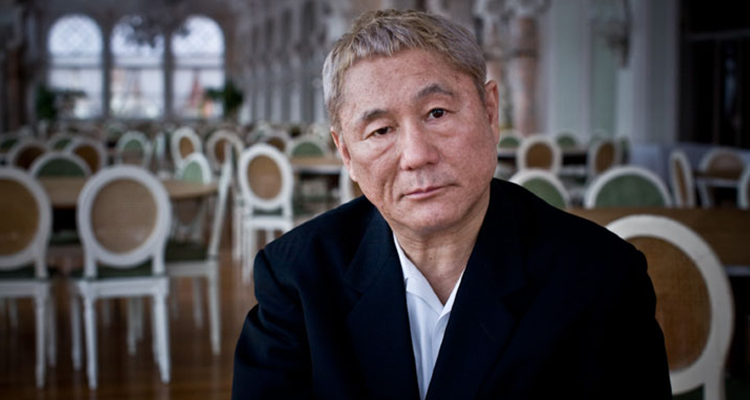Describe the significance of the setting in this image. The setting, a spacious and well-lit restaurant with neatly arranged tables and chairs, suggests a formal or upscale environment. The emptiness of the venue might symbolize solitude or a moment prior to or after a significant event, emphasizing the subject's isolation and accentuating his thoughtful state. 